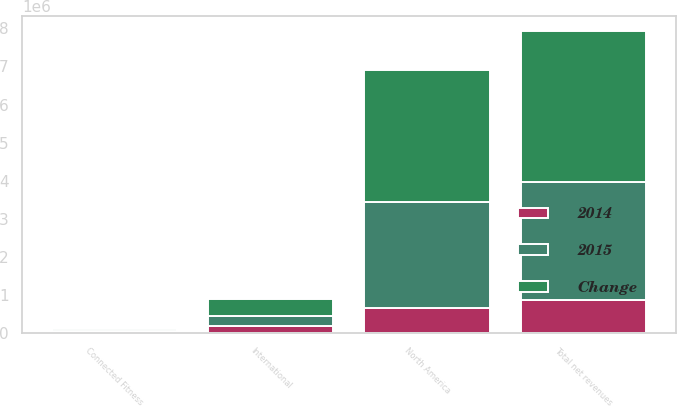<chart> <loc_0><loc_0><loc_500><loc_500><stacked_bar_chart><ecel><fcel>North America<fcel>International<fcel>Connected Fitness<fcel>Total net revenues<nl><fcel>Change<fcel>3.45574e+06<fcel>454161<fcel>53415<fcel>3.96331e+06<nl><fcel>2015<fcel>2.79637e+06<fcel>268771<fcel>19225<fcel>3.08437e+06<nl><fcel>2014<fcel>659363<fcel>185390<fcel>34190<fcel>878943<nl></chart> 